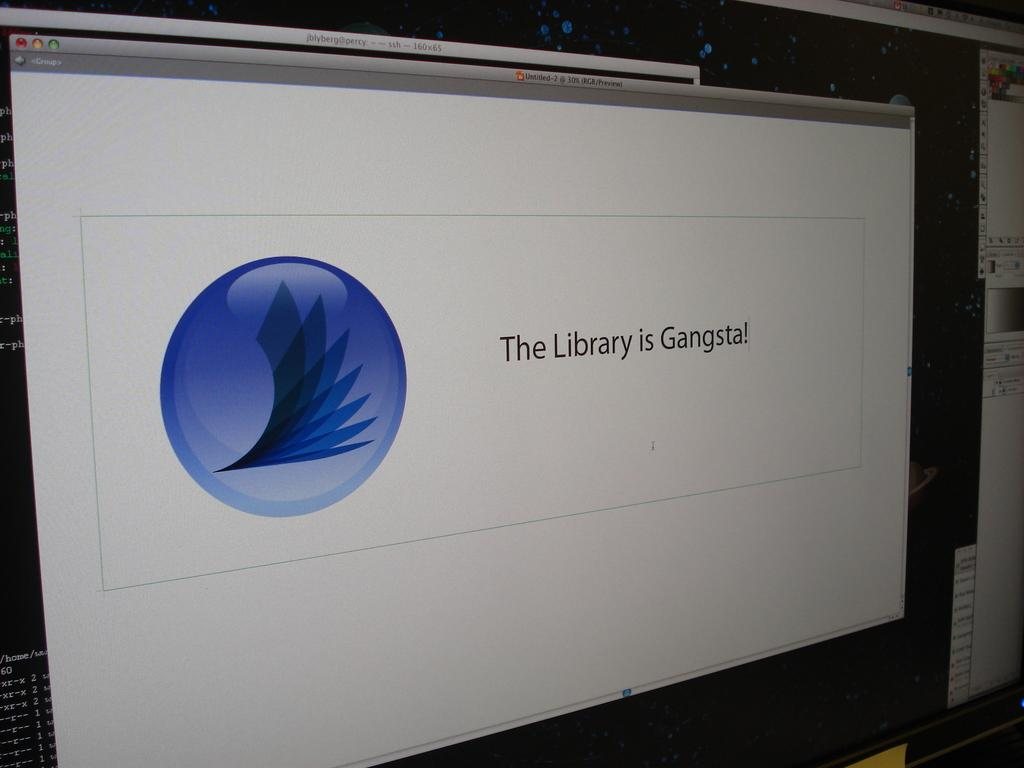<image>
Describe the image concisely. A computer screen that has the words the library is gangsta on it 